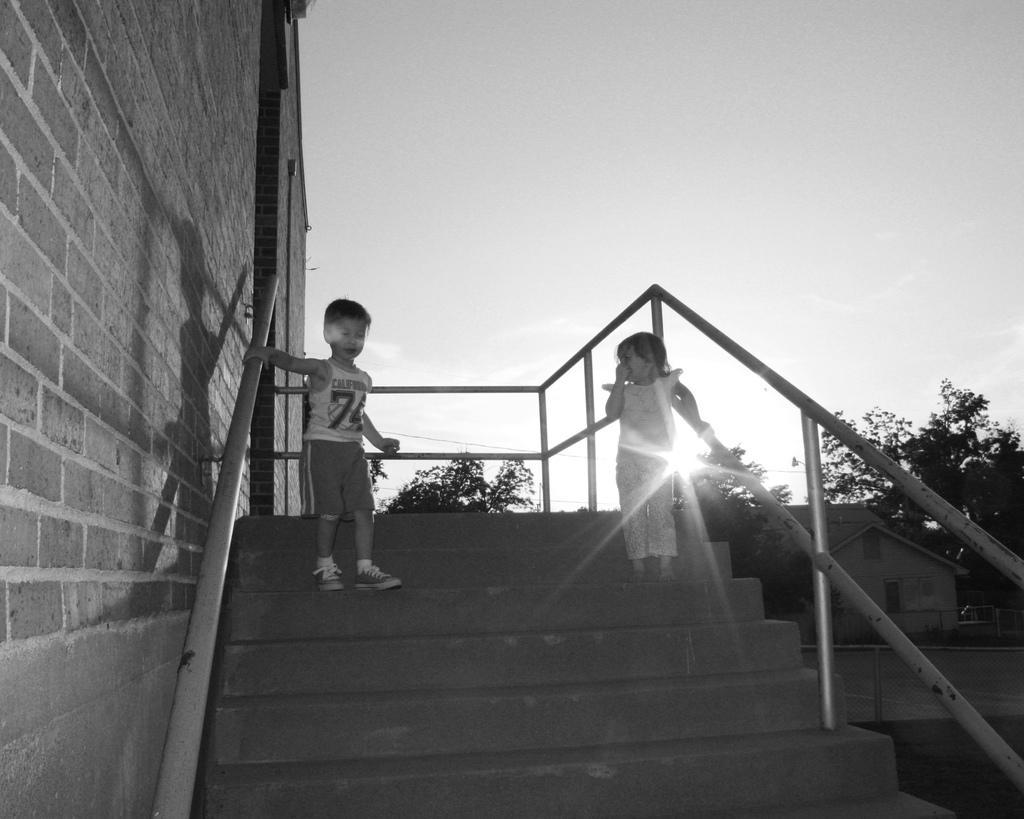In one or two sentences, can you explain what this image depicts? In the image we can see there are two kids standing on the stairs and behind there are lot of trees. There is a building and the image is in black and white colour. 